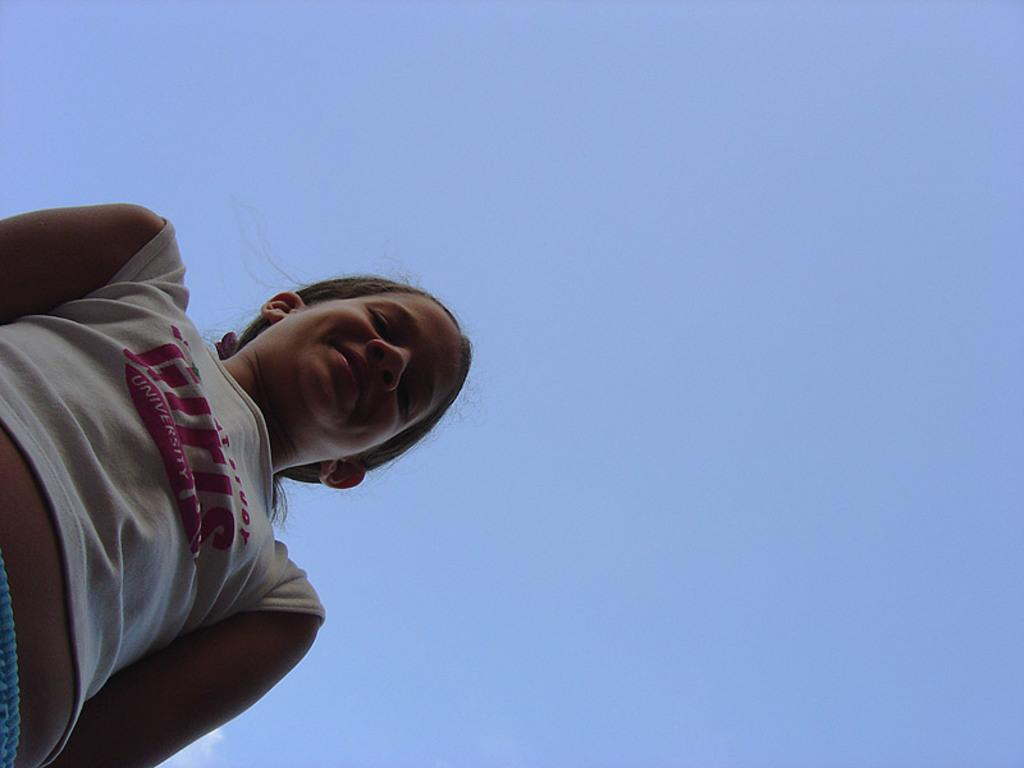What is the main subject of the image? The main subject of the image is a girl. What is the girl doing in the image? The girl is standing and smiling in the image. On which side of the image is the girl located? The girl is on the left side of the image. What can be seen in the background of the image? There is a blue sky visible in the image. Can you see a giraffe at the seashore in the image? There is no giraffe or seashore present in the image. Is the image taken during the night? The image does not indicate that it was taken during the night, as the blue sky suggests it was taken during the day. 